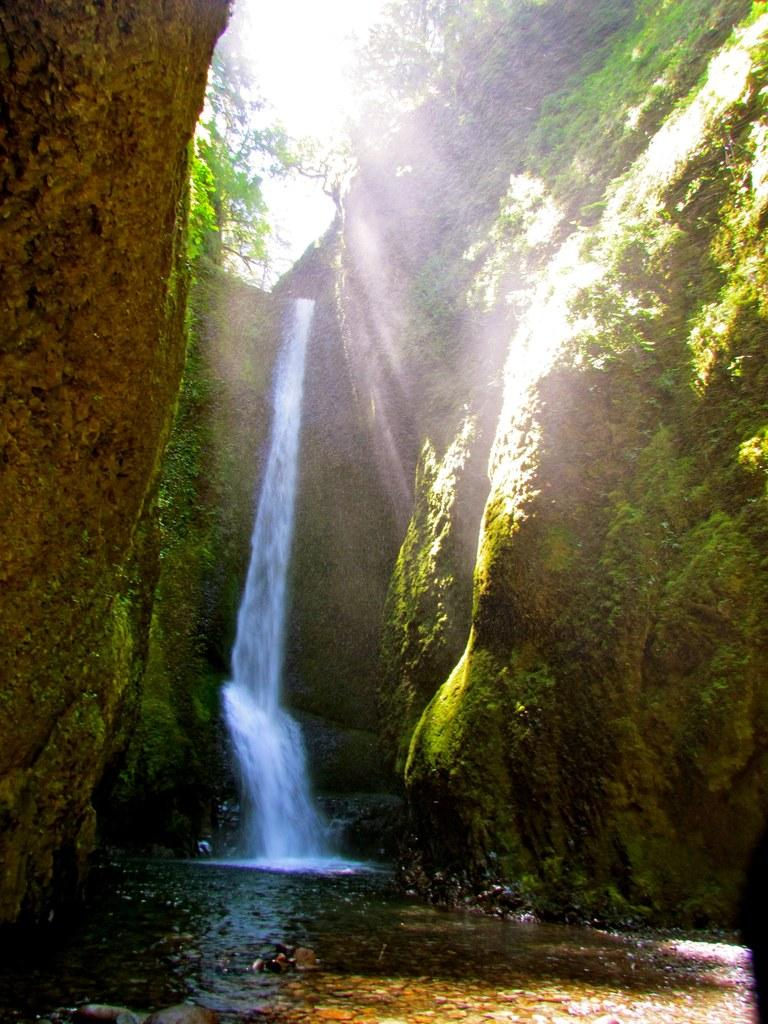What natural feature is the main subject of the picture? There is a waterfall in the picture. What other elements are present in the picture? Rocks and trees are visible in the picture. What can be seen in the background of the picture? The sky is visible in the picture. How is the sunlight affecting the rocks in the picture? Sunlight is falling on the rocks in the picture. How many sticks are being used to hold up the hat in the picture? There are no sticks or hats present in the picture; it features a waterfall, rocks, trees, and the sky. 